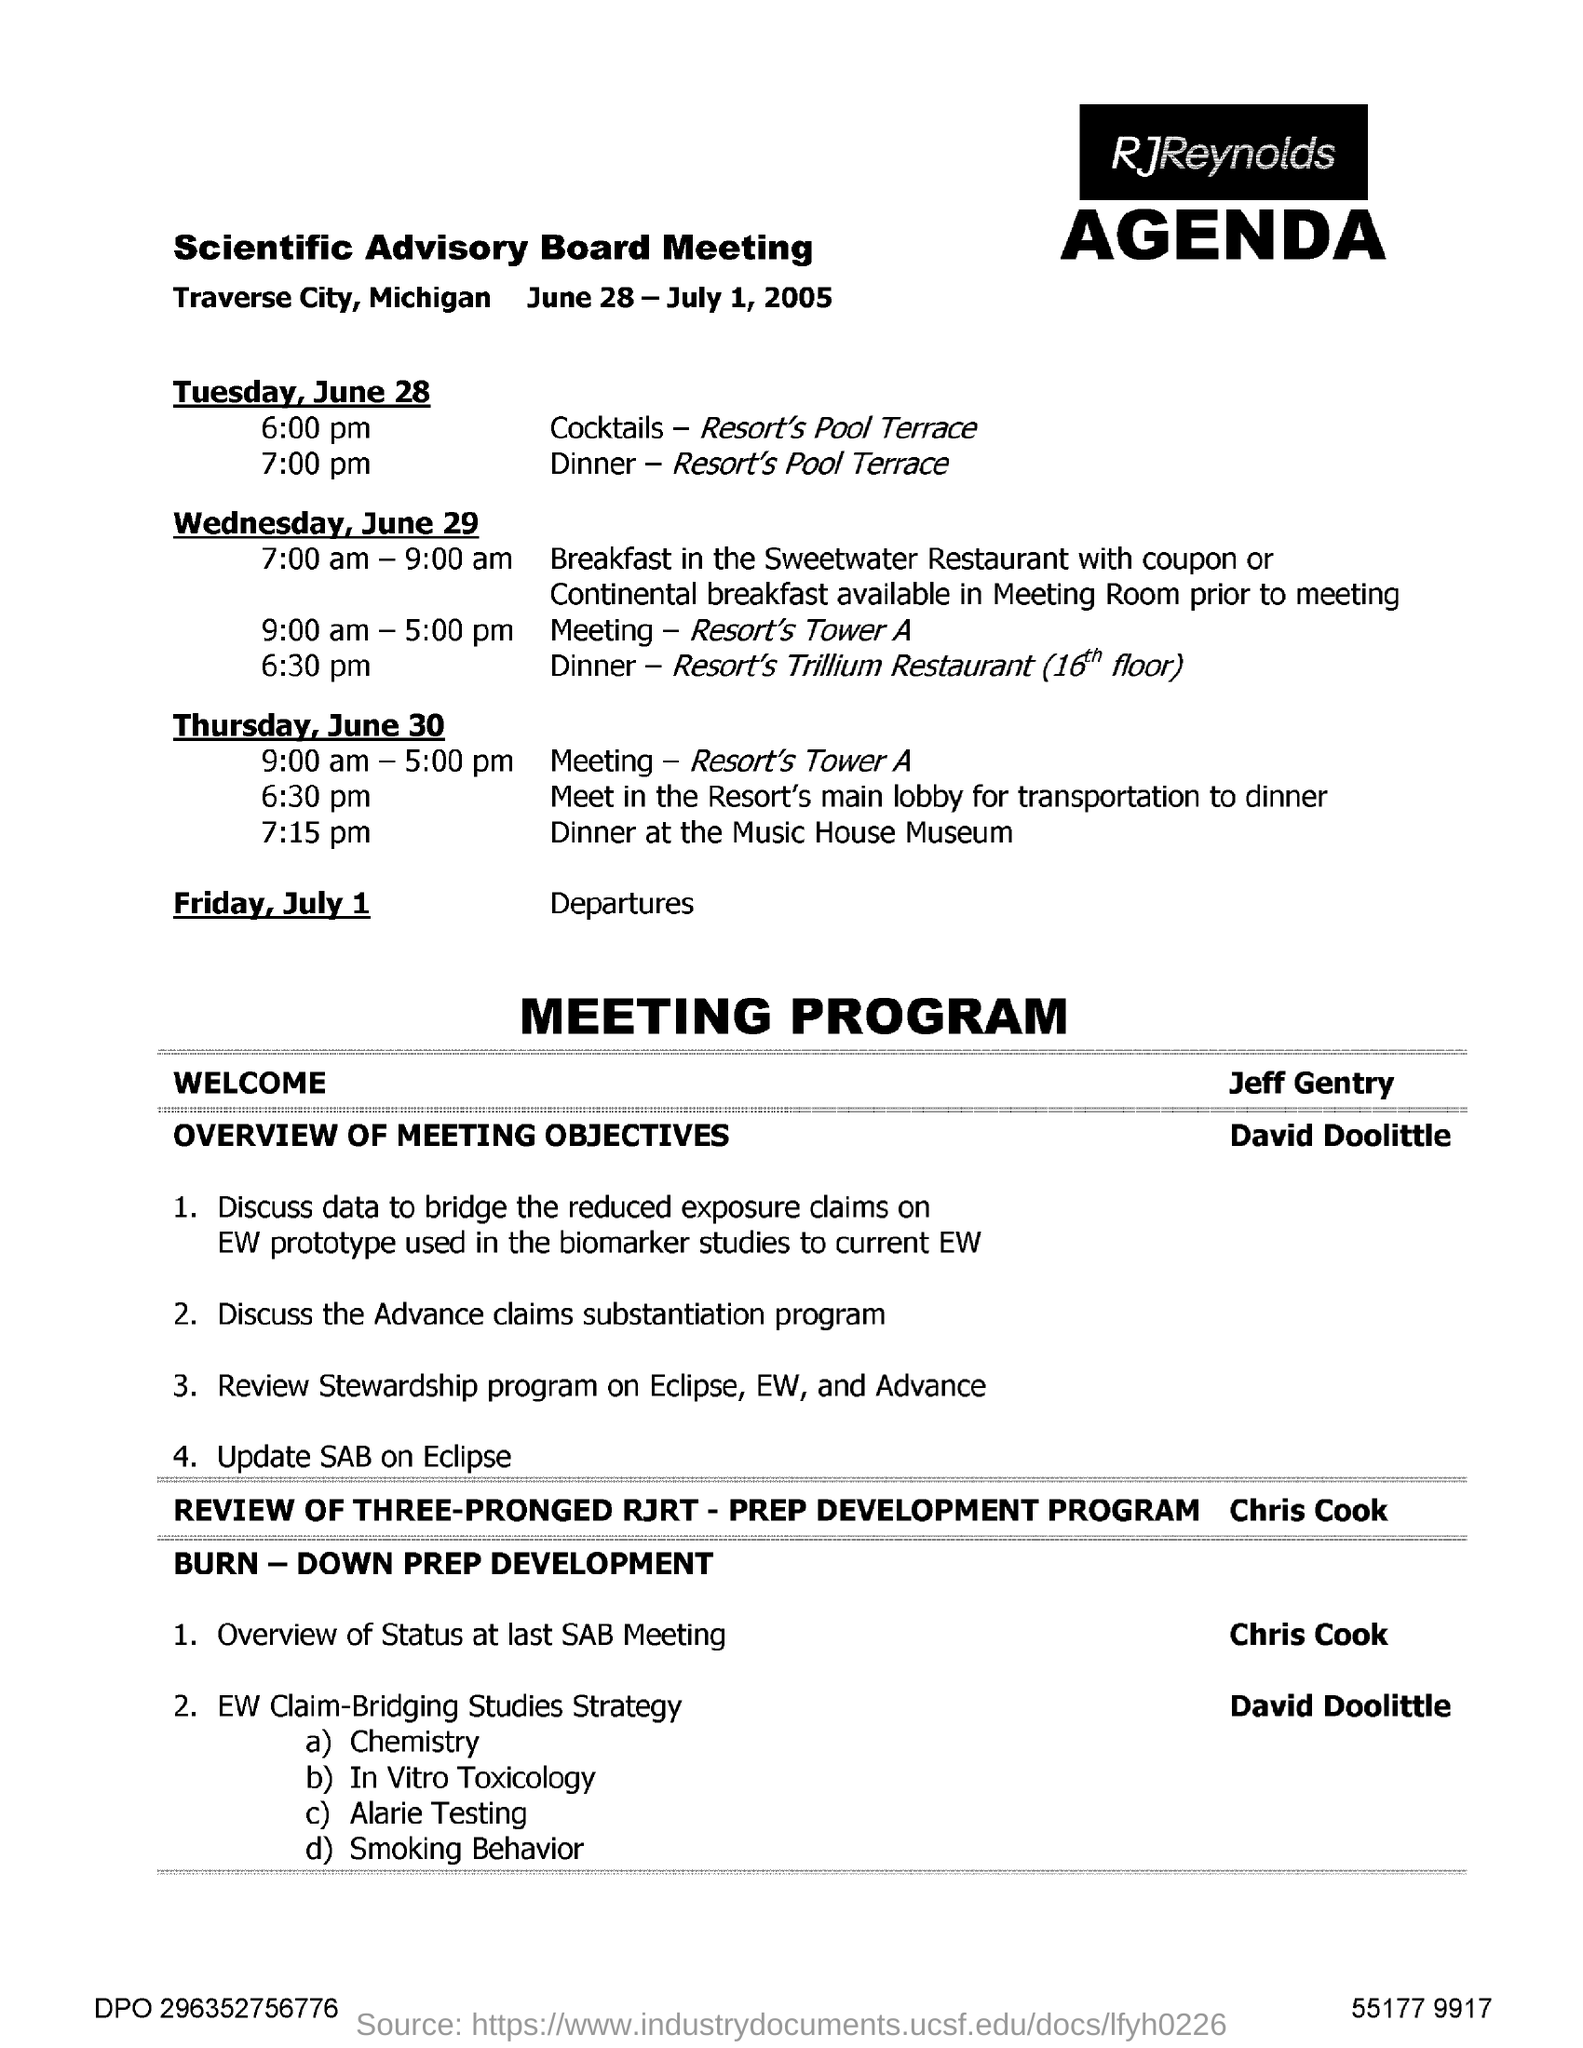When is Scientific Advisory Board Meeting?
Your response must be concise. June 28 - July 1, 2005. Where is Scientific Advisory Board Meeting held?
Offer a terse response. Traverse City, Michigan. 